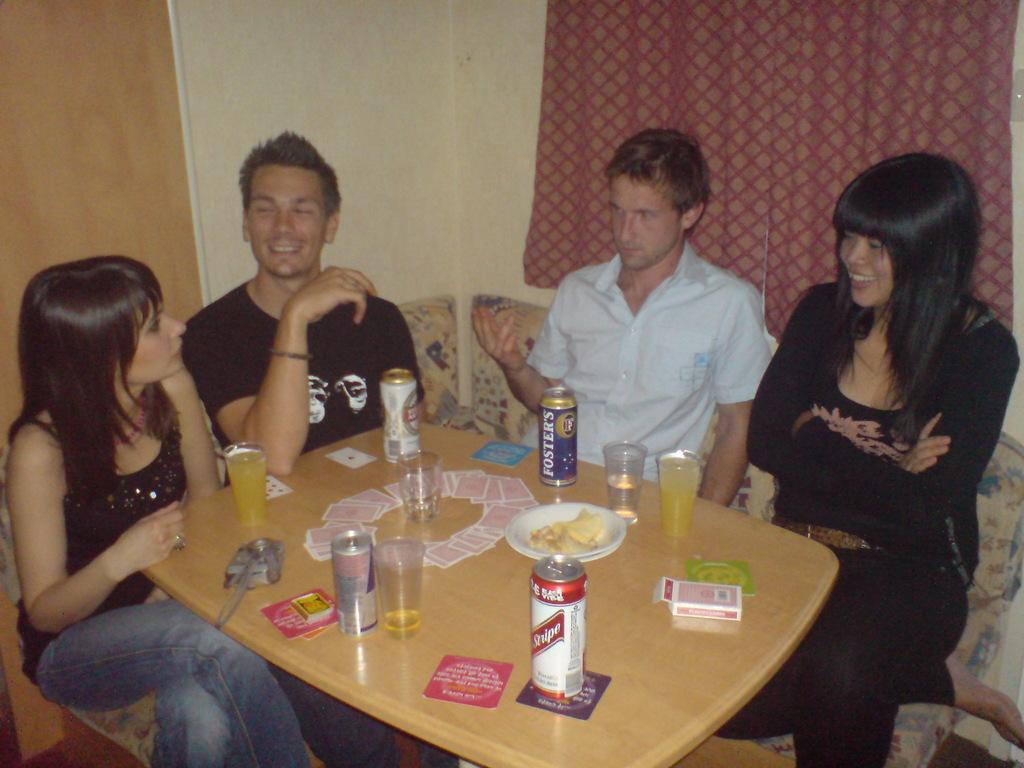Please provide a concise description of this image. As we can see in the image there is a wall, curtain, few people sitting on sofas and a table. On table there is a matchbox, tins, glasses and cards. 